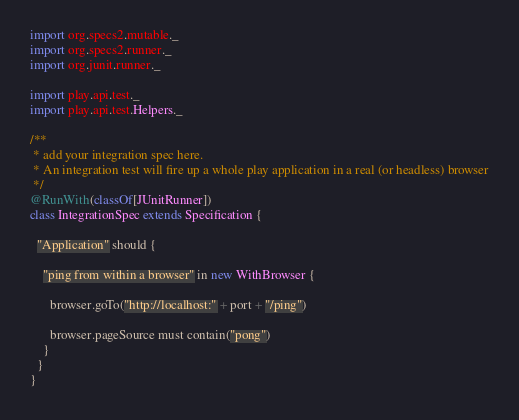Convert code to text. <code><loc_0><loc_0><loc_500><loc_500><_Scala_>import org.specs2.mutable._
import org.specs2.runner._
import org.junit.runner._

import play.api.test._
import play.api.test.Helpers._

/**
 * add your integration spec here.
 * An integration test will fire up a whole play application in a real (or headless) browser
 */
@RunWith(classOf[JUnitRunner])
class IntegrationSpec extends Specification {

  "Application" should {

    "ping from within a browser" in new WithBrowser {

      browser.goTo("http://localhost:" + port + "/ping")

      browser.pageSource must contain("pong")
    }
  }
}
</code> 